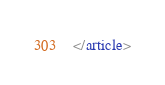<code> <loc_0><loc_0><loc_500><loc_500><_HTML_></article>
</code> 